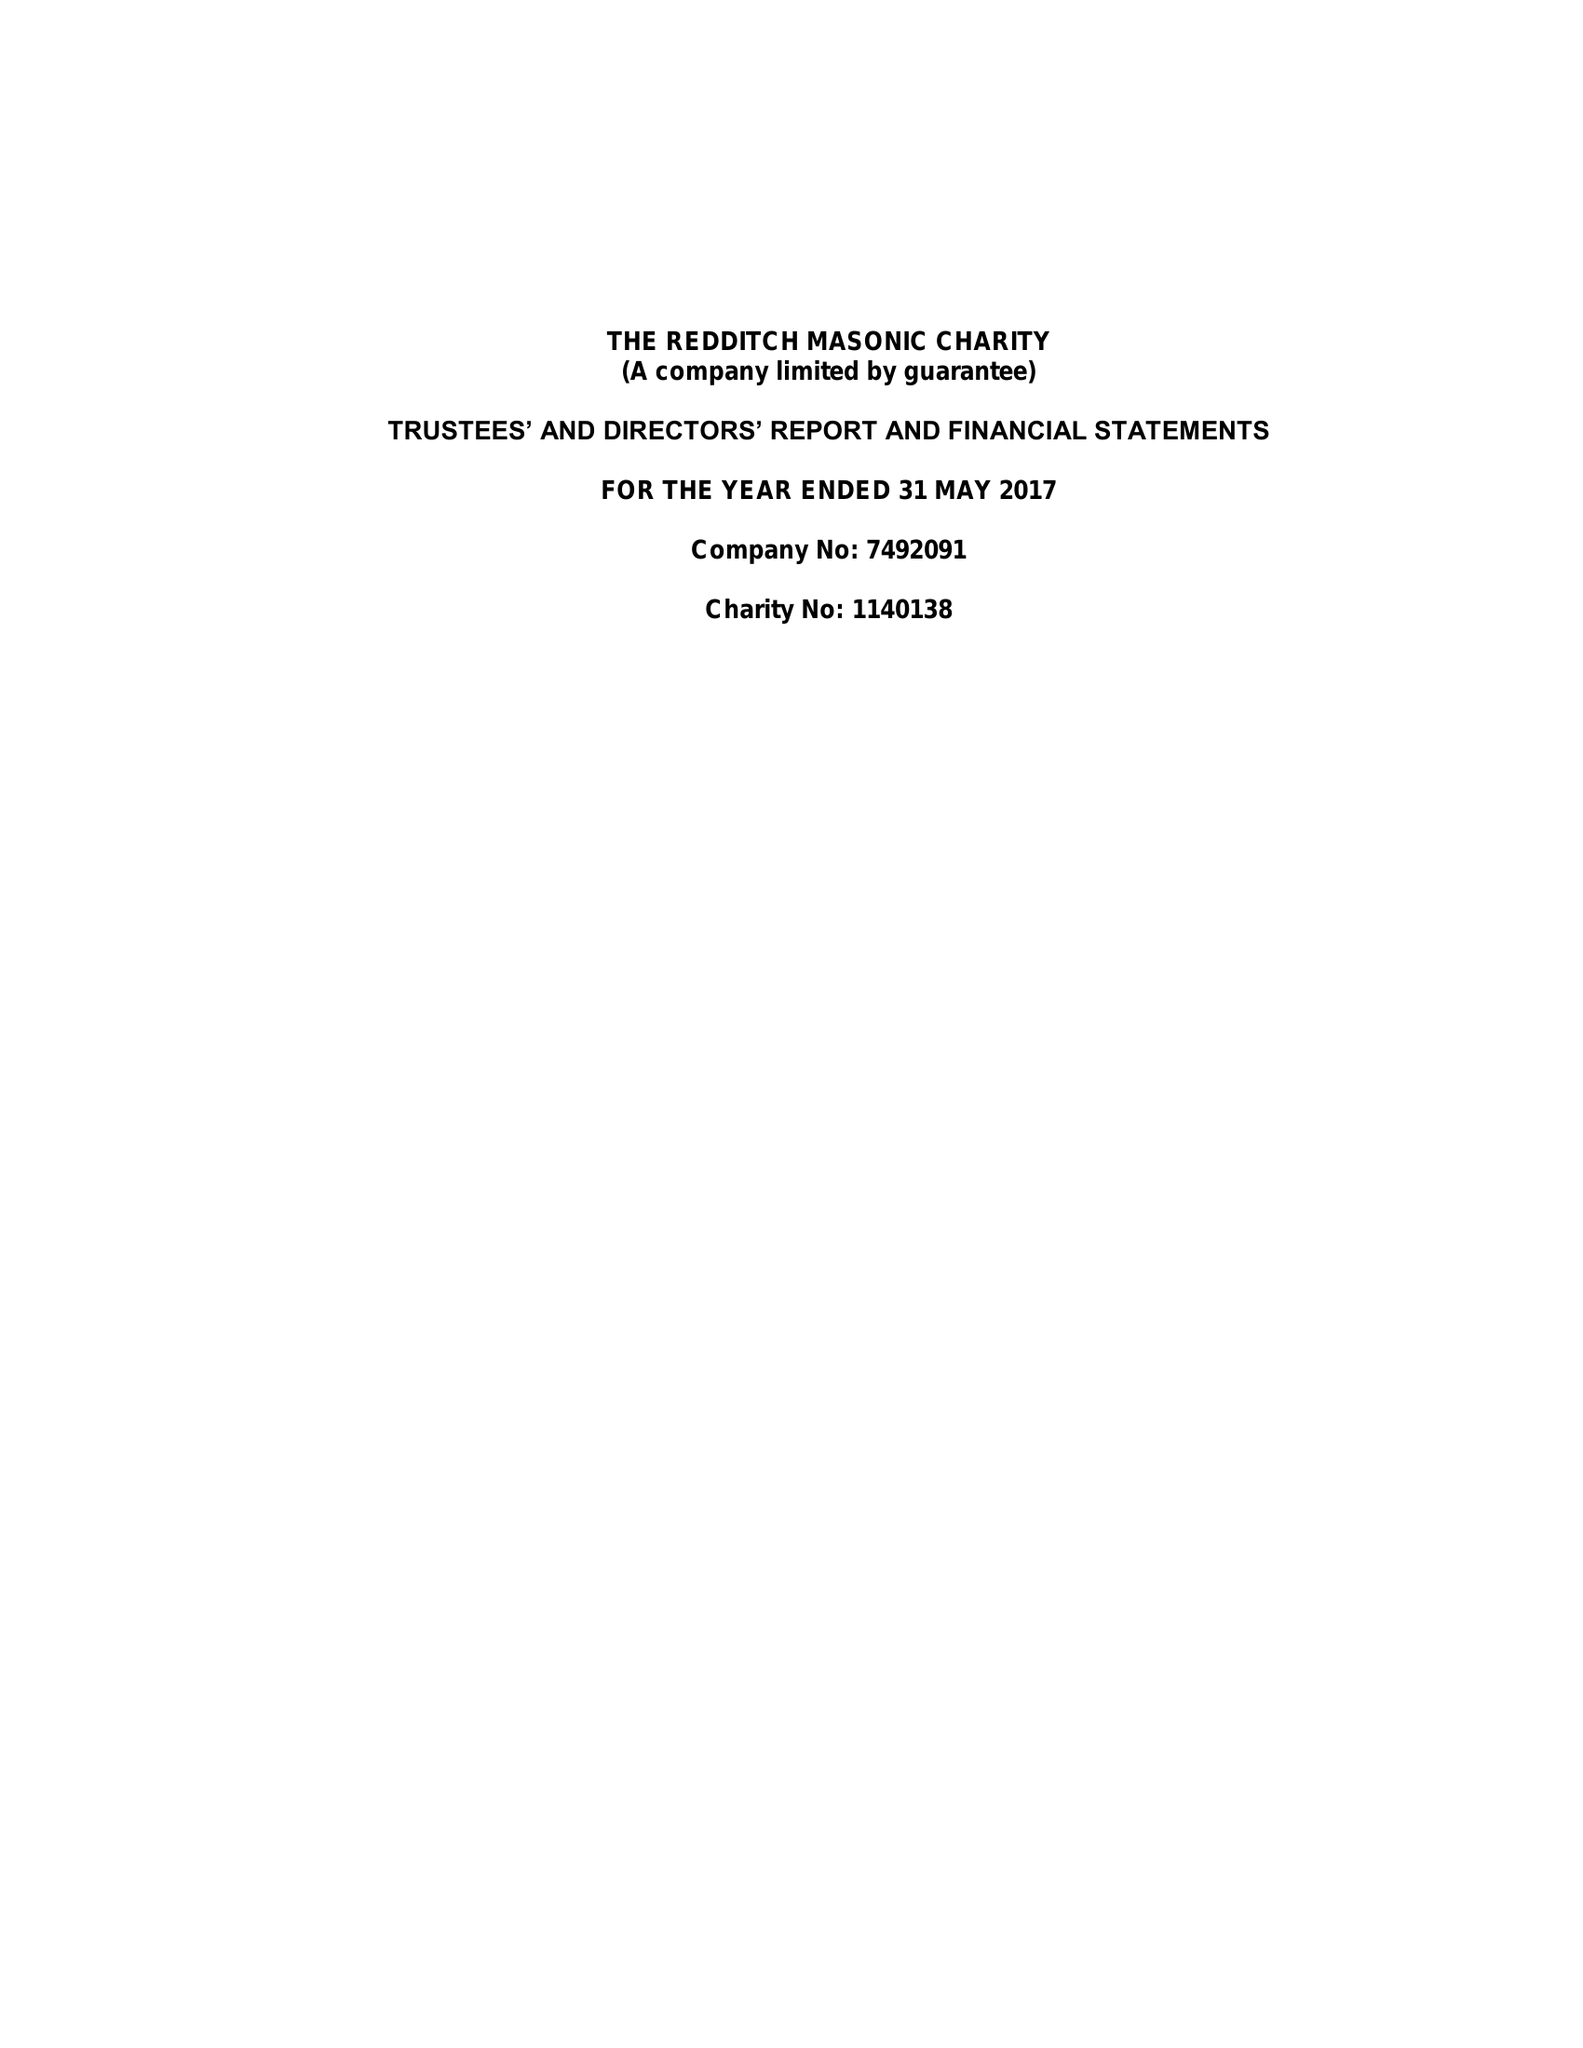What is the value for the charity_number?
Answer the question using a single word or phrase. 1140138 